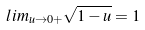Convert formula to latex. <formula><loc_0><loc_0><loc_500><loc_500>l i m _ { u \rightarrow 0 + } \sqrt { 1 - u } = 1</formula> 